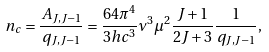Convert formula to latex. <formula><loc_0><loc_0><loc_500><loc_500>n _ { c } = \frac { A _ { J , J - 1 } } { q _ { J , J - 1 } } = \frac { 6 4 \pi ^ { 4 } } { 3 h c ^ { 3 } } \nu ^ { 3 } \mu ^ { 2 } \frac { J + 1 } { 2 J + 3 } \frac { 1 } { q _ { J , J - 1 } } ,</formula> 